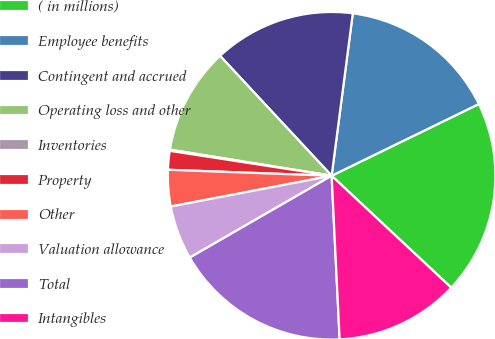Convert chart to OTSL. <chart><loc_0><loc_0><loc_500><loc_500><pie_chart><fcel>( in millions)<fcel>Employee benefits<fcel>Contingent and accrued<fcel>Operating loss and other<fcel>Inventories<fcel>Property<fcel>Other<fcel>Valuation allowance<fcel>Total<fcel>Intangibles<nl><fcel>19.19%<fcel>15.72%<fcel>13.99%<fcel>10.52%<fcel>0.12%<fcel>1.85%<fcel>3.59%<fcel>5.32%<fcel>17.45%<fcel>12.25%<nl></chart> 